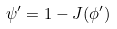<formula> <loc_0><loc_0><loc_500><loc_500>\psi ^ { \prime } = 1 - J ( \phi ^ { \prime } )</formula> 